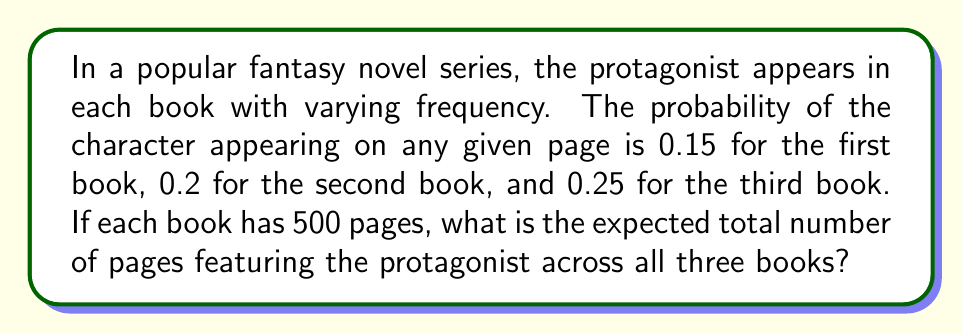Help me with this question. Let's approach this step-by-step:

1) First, we need to calculate the expected number of pages featuring the protagonist for each book separately.

2) For a single book, the number of pages featuring the protagonist follows a binomial distribution. The expected value of a binomial distribution is given by $np$, where $n$ is the number of trials (pages in this case) and $p$ is the probability of success (the protagonist appearing on a page).

3) For Book 1:
   $E(X_1) = 500 \cdot 0.15 = 75$ pages

4) For Book 2:
   $E(X_2) = 500 \cdot 0.2 = 100$ pages

5) For Book 3:
   $E(X_3) = 500 \cdot 0.25 = 125$ pages

6) The total expected number of pages is the sum of the expected values for each book:

   $E(X_{total}) = E(X_1) + E(X_2) + E(X_3)$

7) Substituting the values:

   $E(X_{total}) = 75 + 100 + 125 = 300$ pages

Therefore, the expected total number of pages featuring the protagonist across all three books is 300 pages.
Answer: 300 pages 